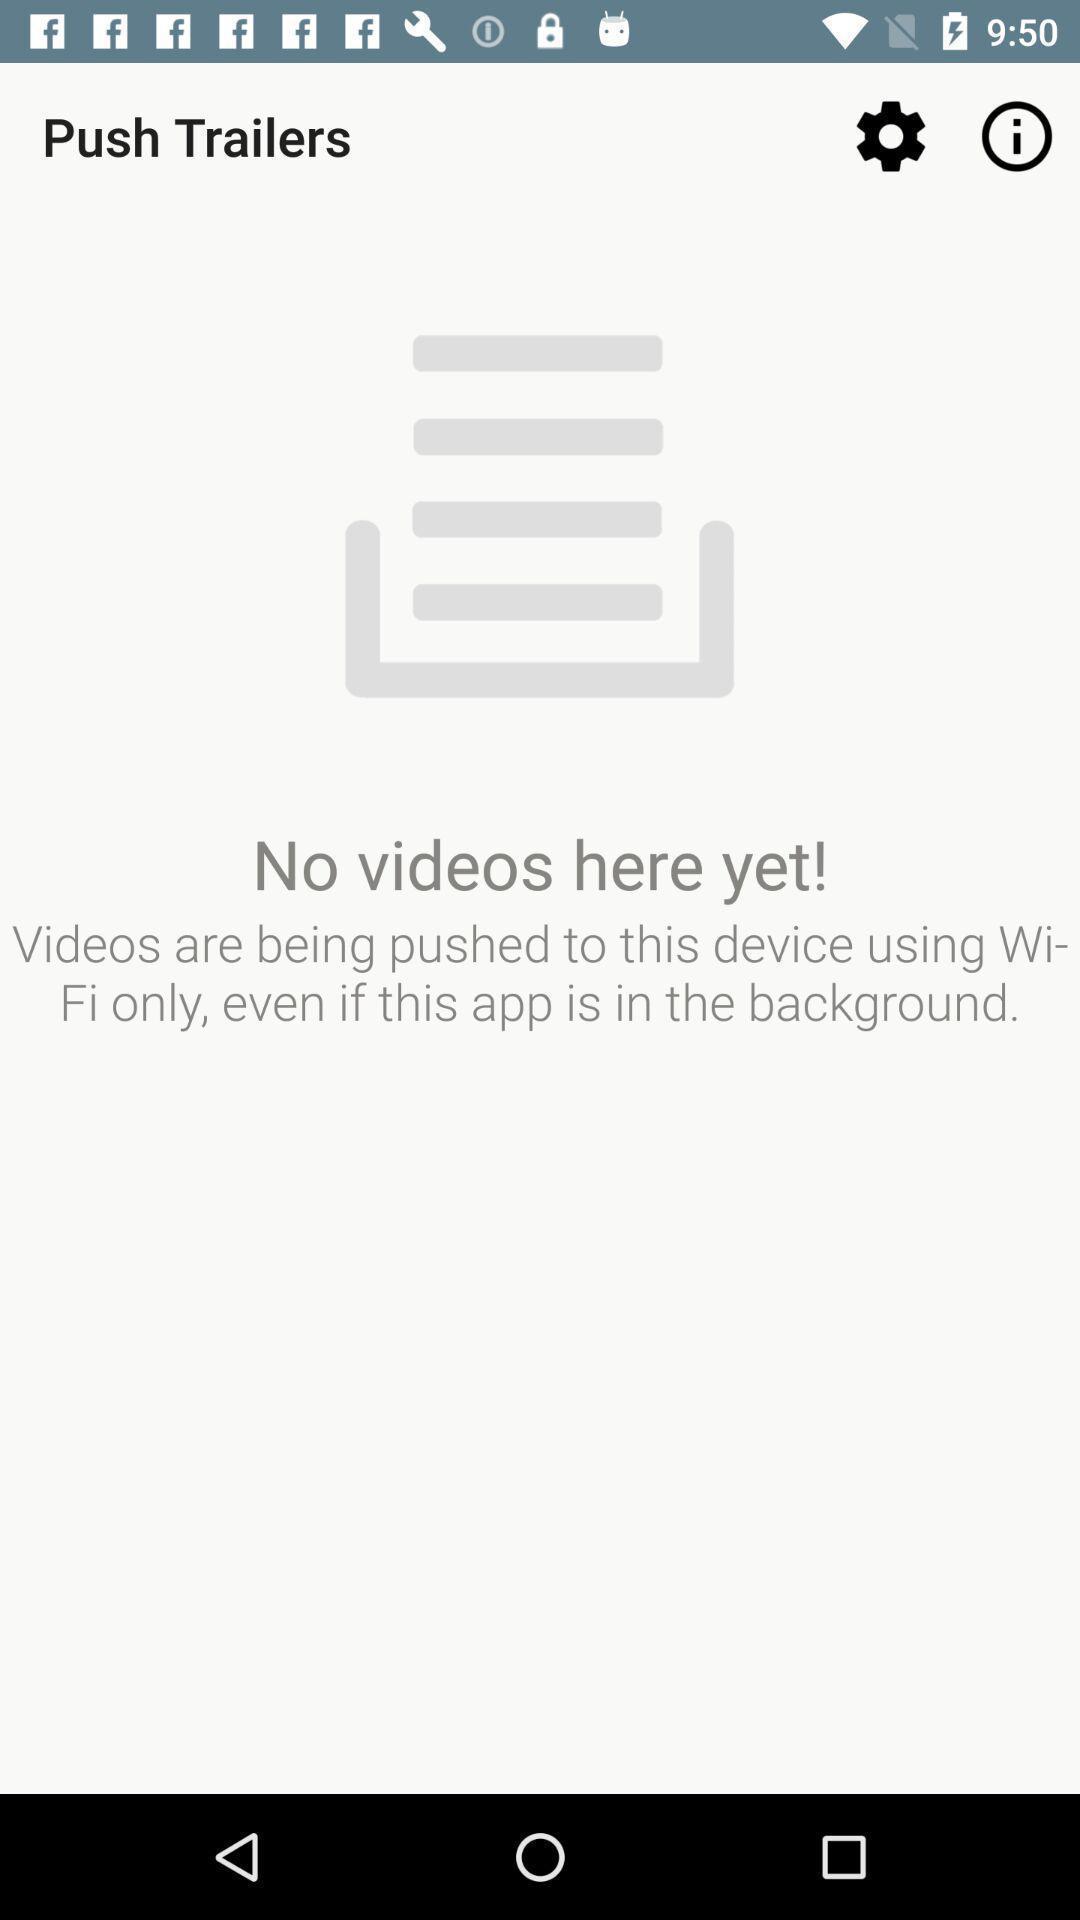What can you discern from this picture? Screen page of an entertainment application. 